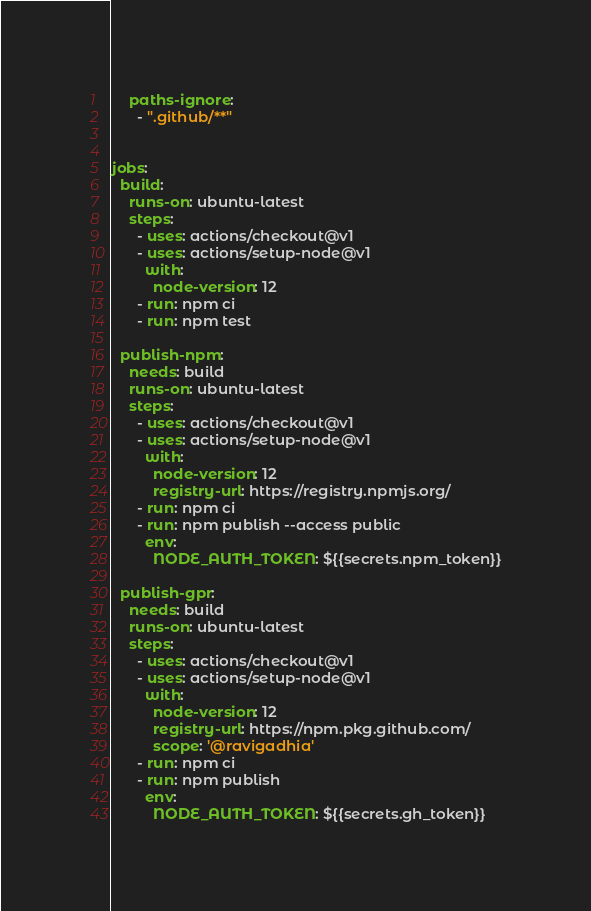<code> <loc_0><loc_0><loc_500><loc_500><_YAML_>    paths-ignore:
      - ".github/**"
          
  
jobs:
  build:
    runs-on: ubuntu-latest
    steps:
      - uses: actions/checkout@v1
      - uses: actions/setup-node@v1
        with:
          node-version: 12
      - run: npm ci
      - run: npm test

  publish-npm:
    needs: build
    runs-on: ubuntu-latest
    steps:
      - uses: actions/checkout@v1
      - uses: actions/setup-node@v1
        with:
          node-version: 12
          registry-url: https://registry.npmjs.org/
      - run: npm ci
      - run: npm publish --access public
        env:
          NODE_AUTH_TOKEN: ${{secrets.npm_token}}

  publish-gpr:
    needs: build
    runs-on: ubuntu-latest
    steps:
      - uses: actions/checkout@v1
      - uses: actions/setup-node@v1
        with:
          node-version: 12
          registry-url: https://npm.pkg.github.com/
          scope: '@ravigadhia'
      - run: npm ci
      - run: npm publish
        env:
          NODE_AUTH_TOKEN: ${{secrets.gh_token}}
</code> 